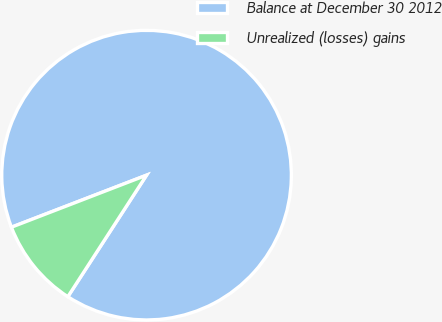Convert chart. <chart><loc_0><loc_0><loc_500><loc_500><pie_chart><fcel>Balance at December 30 2012<fcel>Unrealized (losses) gains<nl><fcel>90.0%<fcel>10.0%<nl></chart> 